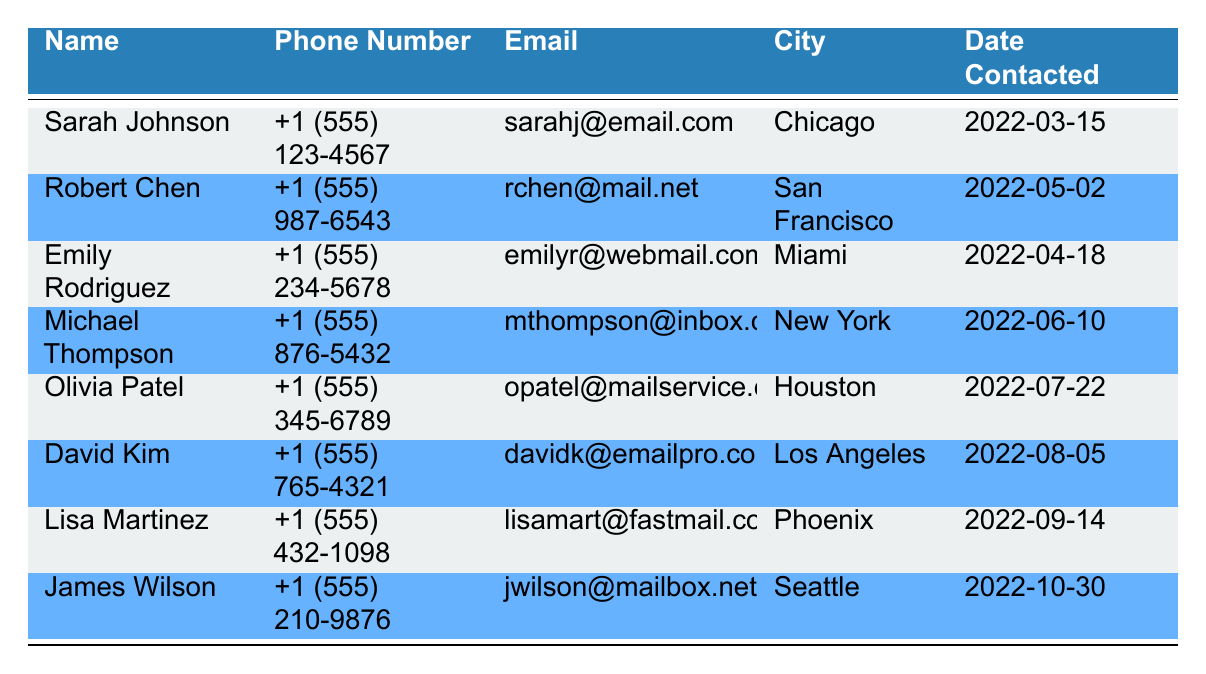What is the phone number of Sarah Johnson? The table lists Sarah Johnson’s phone number in the second column under her name. Therefore, it can be directly retrieved as +1 (555) 123-4567.
Answer: +1 (555) 123-4567 Which city does Michael Thompson live in? By looking at the row for Michael Thompson, his city is noted in the fourth column. He lives in New York.
Answer: New York Did Emily Rodriguez get contacted by the con artist before Robert Chen? Checking the "Date Contacted by Con Artist" for both Emily Rodriguez (2022-04-18) and Robert Chen (2022-05-02), Emily's date is earlier, indicating she was contacted first.
Answer: Yes How many victims are from the state of California? The table indicates that only Robert Chen from San Francisco and David Kim from Los Angeles are in California. By counting, there are 2 individuals from California.
Answer: 2 What was the latest date any of the victims were contacted? To find the latest date, we compare all the "Date Contacted by Con Artist" entries. The latest date listed is for James Wilson on 2022-10-30.
Answer: 2022-10-30 Is there any victim with an email address ending in "mailservice.com"? Inspecting the email addresses, Olivia Patel is the only one with an email ending in "mailservice.com". Therefore, the answer is true.
Answer: Yes Who is the victim from Phoenix, and when were they contacted? The row corresponding to Phoenix lists Lisa Martinez and shows she was contacted on 2022-09-14.
Answer: Lisa Martinez, 2022-09-14 What is the average contact date of all the victims? Each victim's contact date is represented in date format; however, averaging dates requires converting them to a numeric format for accurate calculation. Simply checking averages isn't straightforward in this context without performing date calculations.
Answer: Not applicable 